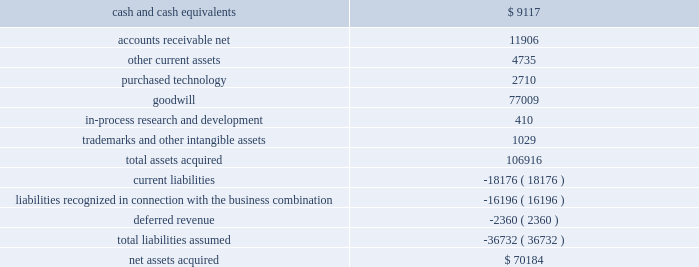2003 and for hedging relationships designated after june 30 , 2003 .
The adoption of sfas 149 did not have a material impact on our consolidated financial position , results of operations or cash flows .
In may 2003 , the fasb issued statement of financial accounting standards no .
150 ( 201csfas 150 201d ) , 201caccounting for certain financial instruments with characteristics of both liabilities and equity . 201d sfas 150 requires that certain financial instruments , which under previous guidance were accounted for as equity , must now be accounted for as liabilities .
The financial instruments affected include mandatory redeemable stock , certain financial instruments that require or may require the issuer to buy back some of its shares in exchange for cash or other assets and certain obligations that can be settled with shares of stock .
Sfas 150 is effective for all financial instruments entered into or modified after may 31 , 2003 , and otherwise is effective at the beginning of the first interim period beginning after june 15 , 2003 .
The adoption of sfas 150 did not have a material impact on our consolidated financial position , results of operations or cash flows .
Note 2 .
Acquisitions on may 19 , 2003 , we purchased the technology assets of syntrillium , a privately held company , for $ 16.5 million cash .
Syntrillium developed , published and marketed digital audio tools including its recording application , cool edit pro ( renamed adobe audition ) , all of which have been added to our existing line of professional digital imaging and video products .
By adding adobe audition and the other tools to our existing line of products , we have improved the adobe video workflow and expanded the products and tools available to videographers , dvd authors and independent filmmakers .
In connection with the purchase , we allocated $ 13.7 million to goodwill , $ 2.7 million to purchased technology and $ 0.1 million to tangible assets .
We also accrued $ 0.1 million in acquisition-related legal and accounting fees .
Goodwill has been allocated to our digital imaging and video segment .
Purchased technology is being amortized to cost of product revenue over its estimated useful life of three years .
The consolidated financial statements include the operating results of the purchased technology assets from the date of purchase .
Pro forma results of operations have not been presented because the effect of this acquisition was not material .
In april 2002 , we acquired all of the outstanding common stock of accelio .
Accelio was a provider of web-enabled solutions that helped customers manage business processes driven by electronic forms .
The acquisition of accelio broadened our epaper solution business .
At the date of acquisition , the aggregate purchase price was $ 70.2 million , which included the issuance of 1.8 million shares of common stock of adobe , valued at $ 68.4 million , and cash of $ 1.8 million .
The table summarizes the purchase price allocation: .
We allocated $ 2.7 million to purchased technology and $ 0.4 million to in-process research and development .
The amount allocated to purchased technology represented the fair market value of the technology for each of the existing products , as of the date of the acquisition .
The purchased technology was assigned a useful life of three years and is being amortized to cost of product revenue .
The amount allocated to in-process research and development was expensed at the time of acquisition due to the state of the development of certain products and the uncertainty of the technology .
The remaining purchase price was allocated to goodwill and was assigned to our epaper segment ( which was renamed intelligent documents beginning in fiscal 2004 ) .
In accordance with sfas no .
142 .
What is the average price of common stock of adobe used in the acquisition of accelio? 
Computations: (68.4 / 1.8)
Answer: 38.0. 